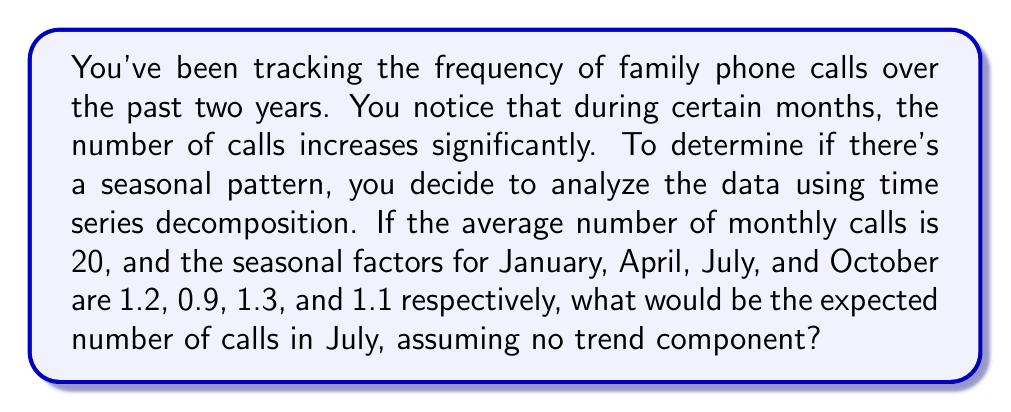Give your solution to this math problem. To solve this problem, we need to understand the components of time series decomposition and how to use seasonal factors. The multiplicative model for time series decomposition is:

$$Y_t = T_t \times S_t \times I_t$$

Where:
$Y_t$ is the observed value
$T_t$ is the trend component
$S_t$ is the seasonal component
$I_t$ is the irregular component

In this case, we're told there's no trend component, so we can simplify our model to:

$$Y_t = \bar{Y} \times S_t$$

Where $\bar{Y}$ is the average number of monthly calls.

We're given:
$\bar{Y} = 20$ calls per month
$S_{\text{July}} = 1.3$

To find the expected number of calls in July, we multiply the average by the seasonal factor:

$$Y_{\text{July}} = 20 \times 1.3 = 26$$

This means we would expect 26 calls in July, based on the seasonal pattern.

The interpretation of the seasonal factor 1.3 for July is that we expect 30% more calls than average during this month, which could be attributed to summer vacations and increased family communication during this time.
Answer: 26 calls 